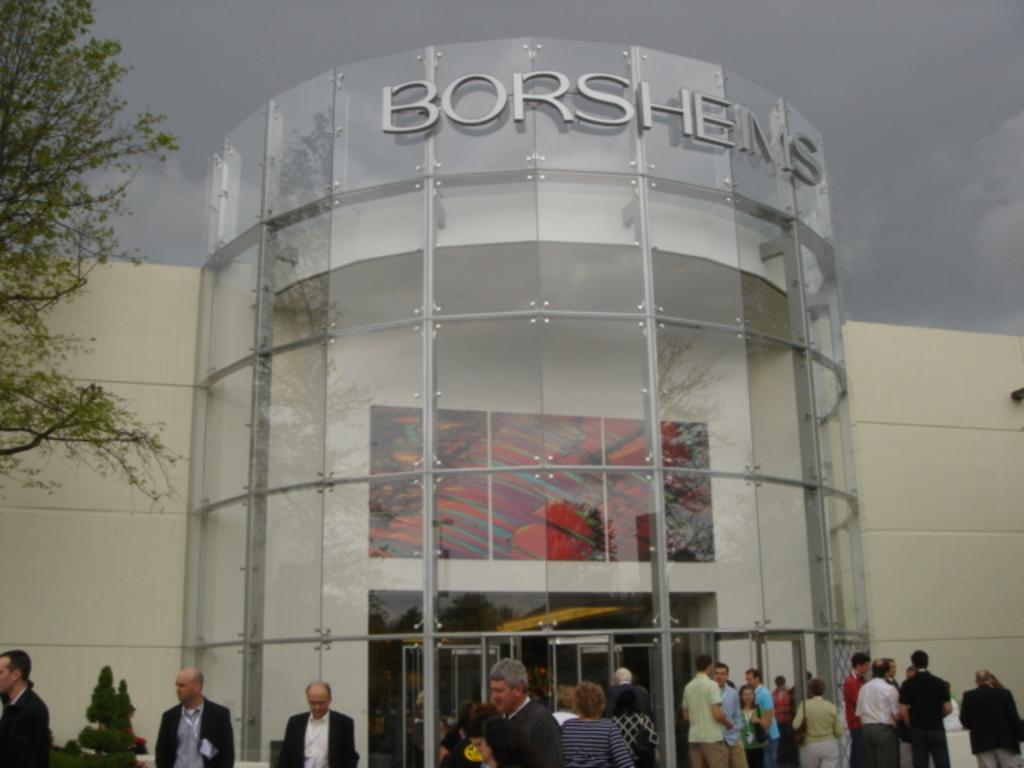How many people are in the image? There is a group of people in the image, but the exact number is not specified. What can be observed about the people's clothing? The people are wearing different color dresses. What is located in front of the people? There is a tree and a building in front of the people. How would you describe the sky in the image? The sky is cloudy in the image. What type of nail is being hammered into the tree in the image? There is no nail being hammered into the tree in the image. Can you see any rifles in the hands of the people in the image? There are no rifles visible in the image. 